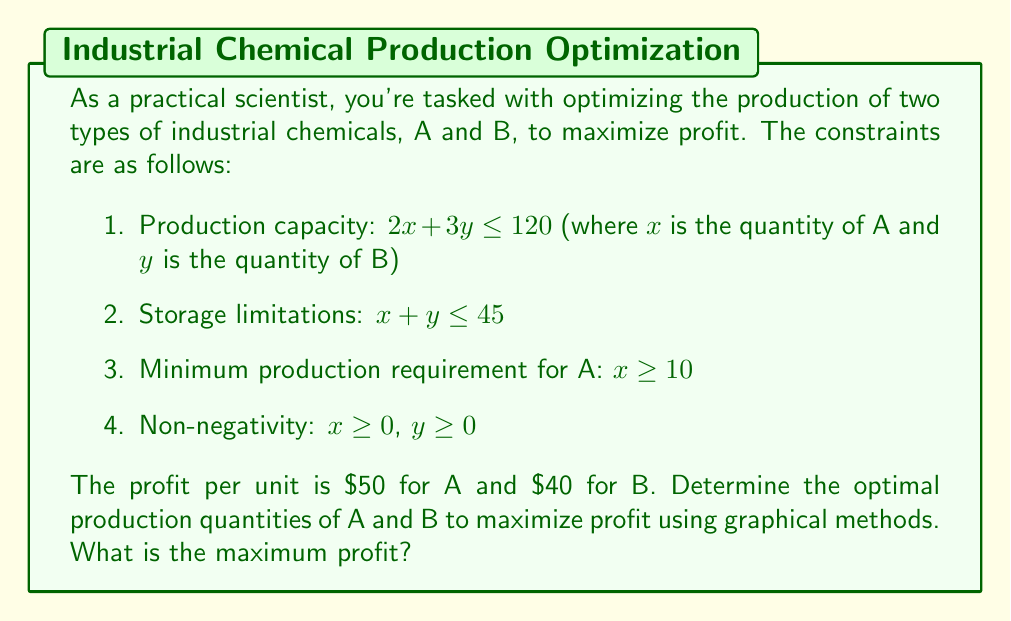Provide a solution to this math problem. Let's approach this problem systematically:

1) First, we'll graph the constraints:

   a) $2x + 3y \leq 120$
   b) $x + y \leq 45$
   c) $x \geq 10$
   d) $x \geq 0$, $y \geq 0$

2) The feasible region is the area that satisfies all these constraints.

3) The objective function is $P = 50x + 40y$, where P is the profit.

4) To find the optimal solution, we'll identify the corner points of the feasible region:

   Point A: (10, 0)
   Point B: (10, 35)
   Point C: (30, 15)
   Point D: (45, 0)

5) We'll evaluate the profit function at each of these points:

   A: $P = 50(10) + 40(0) = 500$
   B: $P = 50(10) + 40(35) = 1900$
   C: $P = 50(30) + 40(15) = 2100$
   D: $P = 50(45) + 40(0) = 2250$

6) The point that yields the maximum profit is D (45, 0).

[asy]
unitsize(4mm);
defaultpen(fontsize(10pt));

// Draw axes
draw((-5,0)--(50,0),arrow=Arrow(DefaultHead));
draw((0,-5)--(0,50),arrow=Arrow(DefaultHead));

// Label axes
label("x", (50,0), E);
label("y", (0,50), N);

// Draw constraints
draw((0,40)--(60,0), blue);
draw((0,45)--(45,0), red);
draw((10,0)--(10,50), green);

// Shade feasible region
fill((10,0)--(10,35)--(30,15)--(45,0)--cycle, lightgray);

// Label key points
dot((10,0)); label("A (10,0)", (10,0), SW);
dot((10,35)); label("B (10,35)", (10,35), NE);
dot((30,15)); label("C (30,15)", (30,15), NE);
dot((45,0)); label("D (45,0)", (45,0), SE);

// Label constraints
label("2x + 3y = 120", (50,7), E, blue);
label("x + y = 45", (40,10), SE, red);
label("x = 10", (10,45), N, green);
[/asy]
Answer: The optimal solution is to produce 45 units of chemical A and 0 units of chemical B, resulting in a maximum profit of $2250. 